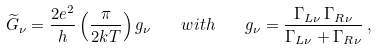Convert formula to latex. <formula><loc_0><loc_0><loc_500><loc_500>\widetilde { G } _ { \nu } = \frac { 2 e ^ { 2 } } { h } \left ( \frac { \pi } { 2 k T } \right ) g _ { \nu } \quad w i t h \quad g _ { \nu } = \frac { \Gamma _ { L \nu } \, \Gamma _ { R \nu } } { \Gamma _ { L \nu } + \Gamma _ { R \nu } } \, ,</formula> 